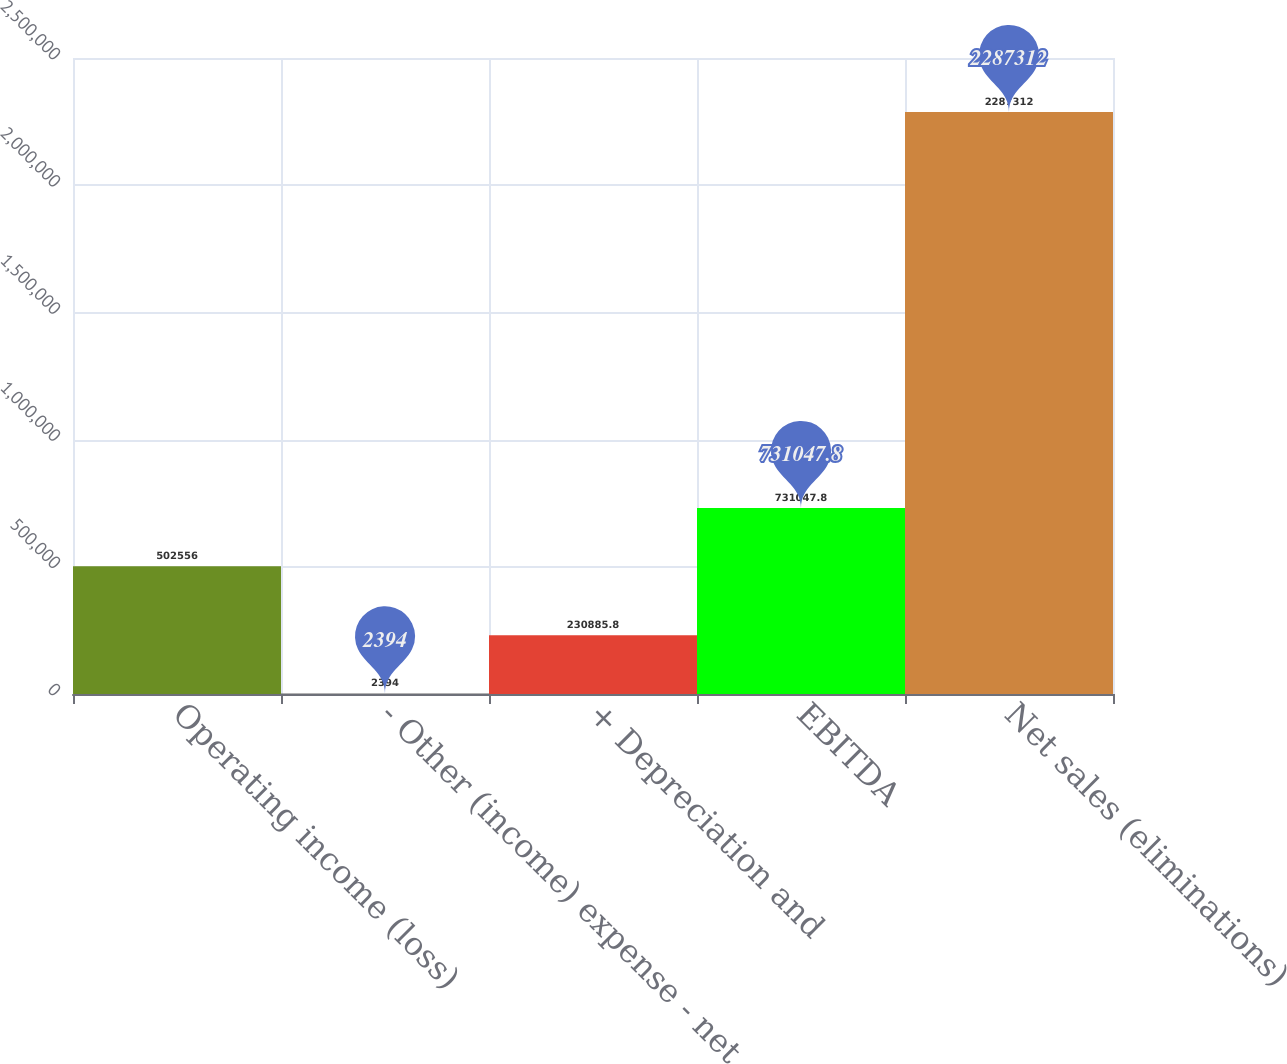<chart> <loc_0><loc_0><loc_500><loc_500><bar_chart><fcel>Operating income (loss)<fcel>- Other (income) expense - net<fcel>+ Depreciation and<fcel>EBITDA<fcel>Net sales (eliminations)<nl><fcel>502556<fcel>2394<fcel>230886<fcel>731048<fcel>2.28731e+06<nl></chart> 